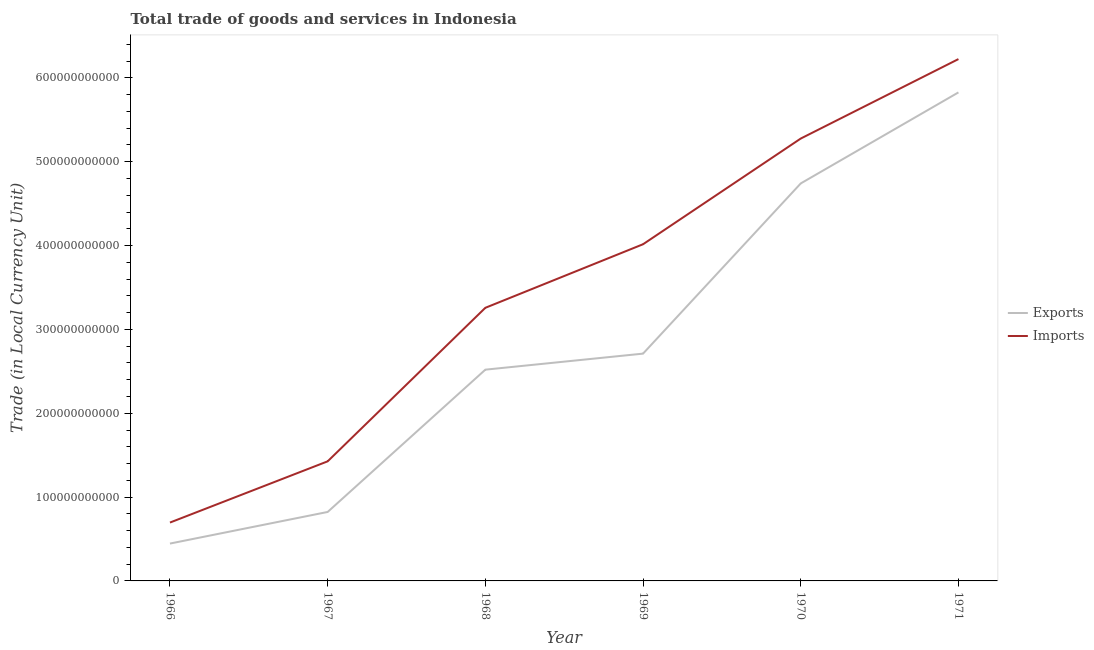Does the line corresponding to imports of goods and services intersect with the line corresponding to export of goods and services?
Keep it short and to the point. No. Is the number of lines equal to the number of legend labels?
Your answer should be very brief. Yes. What is the imports of goods and services in 1968?
Offer a very short reply. 3.26e+11. Across all years, what is the maximum imports of goods and services?
Keep it short and to the point. 6.22e+11. Across all years, what is the minimum imports of goods and services?
Offer a very short reply. 6.96e+1. In which year was the imports of goods and services maximum?
Your answer should be compact. 1971. In which year was the imports of goods and services minimum?
Offer a terse response. 1966. What is the total imports of goods and services in the graph?
Provide a short and direct response. 2.09e+12. What is the difference between the imports of goods and services in 1966 and that in 1967?
Give a very brief answer. -7.30e+1. What is the difference between the export of goods and services in 1970 and the imports of goods and services in 1967?
Give a very brief answer. 3.31e+11. What is the average export of goods and services per year?
Your answer should be very brief. 2.84e+11. In the year 1966, what is the difference between the export of goods and services and imports of goods and services?
Your answer should be very brief. -2.51e+1. In how many years, is the imports of goods and services greater than 320000000000 LCU?
Give a very brief answer. 4. What is the ratio of the imports of goods and services in 1968 to that in 1969?
Provide a succinct answer. 0.81. Is the export of goods and services in 1966 less than that in 1969?
Give a very brief answer. Yes. Is the difference between the export of goods and services in 1969 and 1971 greater than the difference between the imports of goods and services in 1969 and 1971?
Offer a very short reply. No. What is the difference between the highest and the second highest export of goods and services?
Provide a short and direct response. 1.09e+11. What is the difference between the highest and the lowest export of goods and services?
Ensure brevity in your answer.  5.38e+11. Is the export of goods and services strictly less than the imports of goods and services over the years?
Offer a terse response. Yes. What is the difference between two consecutive major ticks on the Y-axis?
Make the answer very short. 1.00e+11. Does the graph contain grids?
Give a very brief answer. No. Where does the legend appear in the graph?
Offer a terse response. Center right. What is the title of the graph?
Your answer should be compact. Total trade of goods and services in Indonesia. What is the label or title of the X-axis?
Provide a succinct answer. Year. What is the label or title of the Y-axis?
Give a very brief answer. Trade (in Local Currency Unit). What is the Trade (in Local Currency Unit) in Exports in 1966?
Provide a short and direct response. 4.46e+1. What is the Trade (in Local Currency Unit) of Imports in 1966?
Your answer should be very brief. 6.96e+1. What is the Trade (in Local Currency Unit) in Exports in 1967?
Make the answer very short. 8.23e+1. What is the Trade (in Local Currency Unit) of Imports in 1967?
Your answer should be very brief. 1.43e+11. What is the Trade (in Local Currency Unit) in Exports in 1968?
Give a very brief answer. 2.52e+11. What is the Trade (in Local Currency Unit) of Imports in 1968?
Give a very brief answer. 3.26e+11. What is the Trade (in Local Currency Unit) of Exports in 1969?
Offer a terse response. 2.71e+11. What is the Trade (in Local Currency Unit) of Imports in 1969?
Give a very brief answer. 4.02e+11. What is the Trade (in Local Currency Unit) of Exports in 1970?
Your answer should be very brief. 4.74e+11. What is the Trade (in Local Currency Unit) of Imports in 1970?
Your answer should be very brief. 5.28e+11. What is the Trade (in Local Currency Unit) of Exports in 1971?
Make the answer very short. 5.83e+11. What is the Trade (in Local Currency Unit) of Imports in 1971?
Offer a terse response. 6.22e+11. Across all years, what is the maximum Trade (in Local Currency Unit) of Exports?
Ensure brevity in your answer.  5.83e+11. Across all years, what is the maximum Trade (in Local Currency Unit) of Imports?
Provide a succinct answer. 6.22e+11. Across all years, what is the minimum Trade (in Local Currency Unit) of Exports?
Your answer should be very brief. 4.46e+1. Across all years, what is the minimum Trade (in Local Currency Unit) of Imports?
Offer a terse response. 6.96e+1. What is the total Trade (in Local Currency Unit) of Exports in the graph?
Your response must be concise. 1.71e+12. What is the total Trade (in Local Currency Unit) in Imports in the graph?
Provide a short and direct response. 2.09e+12. What is the difference between the Trade (in Local Currency Unit) of Exports in 1966 and that in 1967?
Your answer should be very brief. -3.77e+1. What is the difference between the Trade (in Local Currency Unit) in Imports in 1966 and that in 1967?
Your answer should be compact. -7.30e+1. What is the difference between the Trade (in Local Currency Unit) in Exports in 1966 and that in 1968?
Your answer should be very brief. -2.07e+11. What is the difference between the Trade (in Local Currency Unit) in Imports in 1966 and that in 1968?
Make the answer very short. -2.56e+11. What is the difference between the Trade (in Local Currency Unit) in Exports in 1966 and that in 1969?
Offer a very short reply. -2.27e+11. What is the difference between the Trade (in Local Currency Unit) in Imports in 1966 and that in 1969?
Keep it short and to the point. -3.32e+11. What is the difference between the Trade (in Local Currency Unit) of Exports in 1966 and that in 1970?
Your answer should be compact. -4.30e+11. What is the difference between the Trade (in Local Currency Unit) of Imports in 1966 and that in 1970?
Make the answer very short. -4.58e+11. What is the difference between the Trade (in Local Currency Unit) of Exports in 1966 and that in 1971?
Keep it short and to the point. -5.38e+11. What is the difference between the Trade (in Local Currency Unit) of Imports in 1966 and that in 1971?
Give a very brief answer. -5.53e+11. What is the difference between the Trade (in Local Currency Unit) of Exports in 1967 and that in 1968?
Your answer should be compact. -1.70e+11. What is the difference between the Trade (in Local Currency Unit) in Imports in 1967 and that in 1968?
Make the answer very short. -1.83e+11. What is the difference between the Trade (in Local Currency Unit) in Exports in 1967 and that in 1969?
Provide a short and direct response. -1.89e+11. What is the difference between the Trade (in Local Currency Unit) in Imports in 1967 and that in 1969?
Offer a terse response. -2.59e+11. What is the difference between the Trade (in Local Currency Unit) of Exports in 1967 and that in 1970?
Your answer should be very brief. -3.92e+11. What is the difference between the Trade (in Local Currency Unit) of Imports in 1967 and that in 1970?
Make the answer very short. -3.85e+11. What is the difference between the Trade (in Local Currency Unit) of Exports in 1967 and that in 1971?
Your answer should be very brief. -5.00e+11. What is the difference between the Trade (in Local Currency Unit) in Imports in 1967 and that in 1971?
Keep it short and to the point. -4.80e+11. What is the difference between the Trade (in Local Currency Unit) of Exports in 1968 and that in 1969?
Provide a succinct answer. -1.91e+1. What is the difference between the Trade (in Local Currency Unit) of Imports in 1968 and that in 1969?
Offer a terse response. -7.58e+1. What is the difference between the Trade (in Local Currency Unit) in Exports in 1968 and that in 1970?
Offer a terse response. -2.22e+11. What is the difference between the Trade (in Local Currency Unit) in Imports in 1968 and that in 1970?
Your response must be concise. -2.02e+11. What is the difference between the Trade (in Local Currency Unit) in Exports in 1968 and that in 1971?
Offer a terse response. -3.31e+11. What is the difference between the Trade (in Local Currency Unit) in Imports in 1968 and that in 1971?
Your response must be concise. -2.97e+11. What is the difference between the Trade (in Local Currency Unit) in Exports in 1969 and that in 1970?
Provide a short and direct response. -2.03e+11. What is the difference between the Trade (in Local Currency Unit) of Imports in 1969 and that in 1970?
Your answer should be very brief. -1.26e+11. What is the difference between the Trade (in Local Currency Unit) in Exports in 1969 and that in 1971?
Provide a short and direct response. -3.12e+11. What is the difference between the Trade (in Local Currency Unit) of Imports in 1969 and that in 1971?
Your answer should be compact. -2.21e+11. What is the difference between the Trade (in Local Currency Unit) of Exports in 1970 and that in 1971?
Offer a terse response. -1.09e+11. What is the difference between the Trade (in Local Currency Unit) in Imports in 1970 and that in 1971?
Give a very brief answer. -9.48e+1. What is the difference between the Trade (in Local Currency Unit) in Exports in 1966 and the Trade (in Local Currency Unit) in Imports in 1967?
Your response must be concise. -9.81e+1. What is the difference between the Trade (in Local Currency Unit) of Exports in 1966 and the Trade (in Local Currency Unit) of Imports in 1968?
Ensure brevity in your answer.  -2.81e+11. What is the difference between the Trade (in Local Currency Unit) of Exports in 1966 and the Trade (in Local Currency Unit) of Imports in 1969?
Your answer should be very brief. -3.57e+11. What is the difference between the Trade (in Local Currency Unit) of Exports in 1966 and the Trade (in Local Currency Unit) of Imports in 1970?
Ensure brevity in your answer.  -4.83e+11. What is the difference between the Trade (in Local Currency Unit) of Exports in 1966 and the Trade (in Local Currency Unit) of Imports in 1971?
Your response must be concise. -5.78e+11. What is the difference between the Trade (in Local Currency Unit) of Exports in 1967 and the Trade (in Local Currency Unit) of Imports in 1968?
Your answer should be compact. -2.44e+11. What is the difference between the Trade (in Local Currency Unit) in Exports in 1967 and the Trade (in Local Currency Unit) in Imports in 1969?
Give a very brief answer. -3.19e+11. What is the difference between the Trade (in Local Currency Unit) in Exports in 1967 and the Trade (in Local Currency Unit) in Imports in 1970?
Offer a terse response. -4.45e+11. What is the difference between the Trade (in Local Currency Unit) in Exports in 1967 and the Trade (in Local Currency Unit) in Imports in 1971?
Keep it short and to the point. -5.40e+11. What is the difference between the Trade (in Local Currency Unit) in Exports in 1968 and the Trade (in Local Currency Unit) in Imports in 1969?
Ensure brevity in your answer.  -1.50e+11. What is the difference between the Trade (in Local Currency Unit) of Exports in 1968 and the Trade (in Local Currency Unit) of Imports in 1970?
Give a very brief answer. -2.76e+11. What is the difference between the Trade (in Local Currency Unit) of Exports in 1968 and the Trade (in Local Currency Unit) of Imports in 1971?
Your answer should be very brief. -3.70e+11. What is the difference between the Trade (in Local Currency Unit) in Exports in 1969 and the Trade (in Local Currency Unit) in Imports in 1970?
Give a very brief answer. -2.57e+11. What is the difference between the Trade (in Local Currency Unit) of Exports in 1969 and the Trade (in Local Currency Unit) of Imports in 1971?
Your response must be concise. -3.51e+11. What is the difference between the Trade (in Local Currency Unit) in Exports in 1970 and the Trade (in Local Currency Unit) in Imports in 1971?
Keep it short and to the point. -1.48e+11. What is the average Trade (in Local Currency Unit) in Exports per year?
Your answer should be compact. 2.84e+11. What is the average Trade (in Local Currency Unit) in Imports per year?
Ensure brevity in your answer.  3.48e+11. In the year 1966, what is the difference between the Trade (in Local Currency Unit) in Exports and Trade (in Local Currency Unit) in Imports?
Ensure brevity in your answer.  -2.51e+1. In the year 1967, what is the difference between the Trade (in Local Currency Unit) of Exports and Trade (in Local Currency Unit) of Imports?
Your answer should be very brief. -6.04e+1. In the year 1968, what is the difference between the Trade (in Local Currency Unit) of Exports and Trade (in Local Currency Unit) of Imports?
Your answer should be compact. -7.38e+1. In the year 1969, what is the difference between the Trade (in Local Currency Unit) in Exports and Trade (in Local Currency Unit) in Imports?
Ensure brevity in your answer.  -1.30e+11. In the year 1970, what is the difference between the Trade (in Local Currency Unit) in Exports and Trade (in Local Currency Unit) in Imports?
Your answer should be compact. -5.35e+1. In the year 1971, what is the difference between the Trade (in Local Currency Unit) in Exports and Trade (in Local Currency Unit) in Imports?
Give a very brief answer. -3.97e+1. What is the ratio of the Trade (in Local Currency Unit) in Exports in 1966 to that in 1967?
Provide a succinct answer. 0.54. What is the ratio of the Trade (in Local Currency Unit) of Imports in 1966 to that in 1967?
Your answer should be very brief. 0.49. What is the ratio of the Trade (in Local Currency Unit) in Exports in 1966 to that in 1968?
Provide a succinct answer. 0.18. What is the ratio of the Trade (in Local Currency Unit) of Imports in 1966 to that in 1968?
Make the answer very short. 0.21. What is the ratio of the Trade (in Local Currency Unit) of Exports in 1966 to that in 1969?
Make the answer very short. 0.16. What is the ratio of the Trade (in Local Currency Unit) in Imports in 1966 to that in 1969?
Your response must be concise. 0.17. What is the ratio of the Trade (in Local Currency Unit) of Exports in 1966 to that in 1970?
Provide a succinct answer. 0.09. What is the ratio of the Trade (in Local Currency Unit) of Imports in 1966 to that in 1970?
Your response must be concise. 0.13. What is the ratio of the Trade (in Local Currency Unit) in Exports in 1966 to that in 1971?
Keep it short and to the point. 0.08. What is the ratio of the Trade (in Local Currency Unit) of Imports in 1966 to that in 1971?
Give a very brief answer. 0.11. What is the ratio of the Trade (in Local Currency Unit) in Exports in 1967 to that in 1968?
Offer a terse response. 0.33. What is the ratio of the Trade (in Local Currency Unit) in Imports in 1967 to that in 1968?
Provide a succinct answer. 0.44. What is the ratio of the Trade (in Local Currency Unit) of Exports in 1967 to that in 1969?
Keep it short and to the point. 0.3. What is the ratio of the Trade (in Local Currency Unit) of Imports in 1967 to that in 1969?
Provide a short and direct response. 0.36. What is the ratio of the Trade (in Local Currency Unit) in Exports in 1967 to that in 1970?
Your answer should be compact. 0.17. What is the ratio of the Trade (in Local Currency Unit) in Imports in 1967 to that in 1970?
Ensure brevity in your answer.  0.27. What is the ratio of the Trade (in Local Currency Unit) of Exports in 1967 to that in 1971?
Offer a very short reply. 0.14. What is the ratio of the Trade (in Local Currency Unit) of Imports in 1967 to that in 1971?
Ensure brevity in your answer.  0.23. What is the ratio of the Trade (in Local Currency Unit) in Exports in 1968 to that in 1969?
Ensure brevity in your answer.  0.93. What is the ratio of the Trade (in Local Currency Unit) in Imports in 1968 to that in 1969?
Give a very brief answer. 0.81. What is the ratio of the Trade (in Local Currency Unit) of Exports in 1968 to that in 1970?
Offer a very short reply. 0.53. What is the ratio of the Trade (in Local Currency Unit) of Imports in 1968 to that in 1970?
Give a very brief answer. 0.62. What is the ratio of the Trade (in Local Currency Unit) of Exports in 1968 to that in 1971?
Provide a succinct answer. 0.43. What is the ratio of the Trade (in Local Currency Unit) in Imports in 1968 to that in 1971?
Offer a terse response. 0.52. What is the ratio of the Trade (in Local Currency Unit) in Exports in 1969 to that in 1970?
Offer a terse response. 0.57. What is the ratio of the Trade (in Local Currency Unit) in Imports in 1969 to that in 1970?
Offer a terse response. 0.76. What is the ratio of the Trade (in Local Currency Unit) of Exports in 1969 to that in 1971?
Keep it short and to the point. 0.47. What is the ratio of the Trade (in Local Currency Unit) in Imports in 1969 to that in 1971?
Make the answer very short. 0.65. What is the ratio of the Trade (in Local Currency Unit) in Exports in 1970 to that in 1971?
Give a very brief answer. 0.81. What is the ratio of the Trade (in Local Currency Unit) in Imports in 1970 to that in 1971?
Ensure brevity in your answer.  0.85. What is the difference between the highest and the second highest Trade (in Local Currency Unit) in Exports?
Your response must be concise. 1.09e+11. What is the difference between the highest and the second highest Trade (in Local Currency Unit) in Imports?
Your answer should be very brief. 9.48e+1. What is the difference between the highest and the lowest Trade (in Local Currency Unit) of Exports?
Provide a succinct answer. 5.38e+11. What is the difference between the highest and the lowest Trade (in Local Currency Unit) of Imports?
Your answer should be very brief. 5.53e+11. 